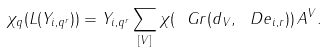<formula> <loc_0><loc_0><loc_500><loc_500>\chi _ { q } ( L ( Y _ { i , q ^ { r } } ) ) = Y _ { i , q ^ { r } } \sum _ { [ V ] } \chi ( \ G r ( d _ { V } , \ D e _ { i , r } ) ) \, A ^ { V } .</formula> 